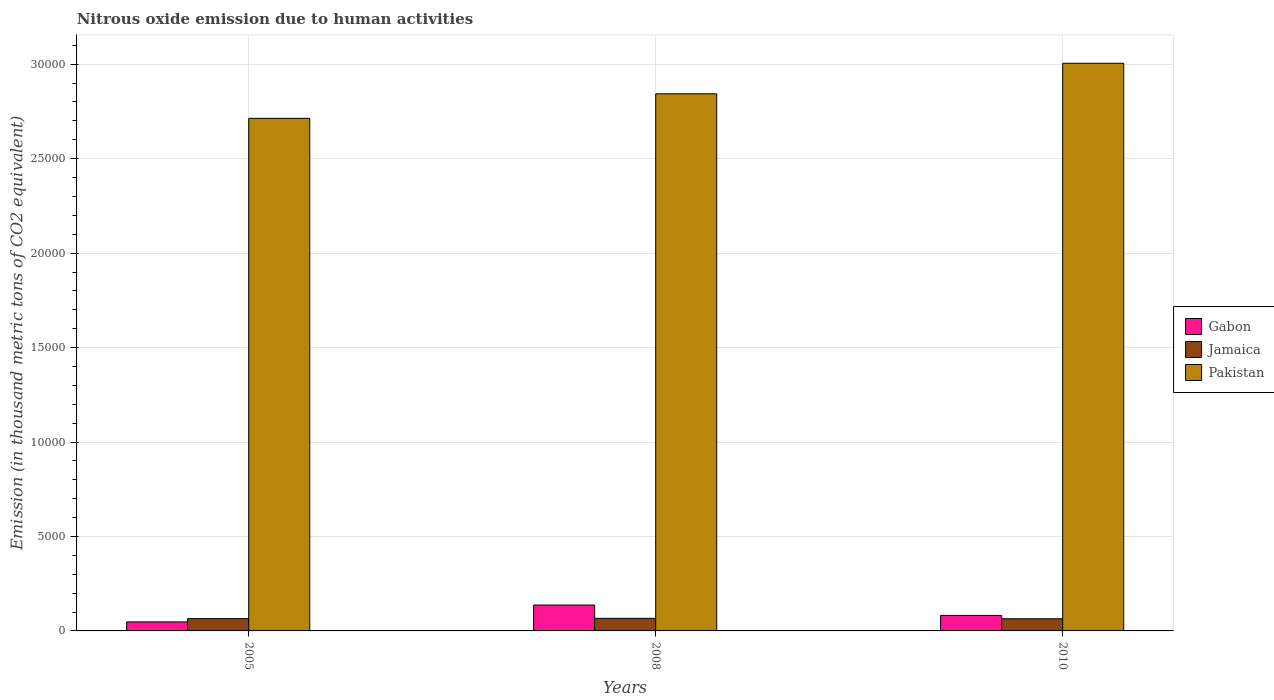Are the number of bars per tick equal to the number of legend labels?
Ensure brevity in your answer.  Yes. Are the number of bars on each tick of the X-axis equal?
Your answer should be compact. Yes. How many bars are there on the 3rd tick from the left?
Provide a short and direct response. 3. How many bars are there on the 1st tick from the right?
Offer a terse response. 3. In how many cases, is the number of bars for a given year not equal to the number of legend labels?
Ensure brevity in your answer.  0. What is the amount of nitrous oxide emitted in Jamaica in 2005?
Ensure brevity in your answer.  650.5. Across all years, what is the maximum amount of nitrous oxide emitted in Jamaica?
Your answer should be very brief. 666.6. Across all years, what is the minimum amount of nitrous oxide emitted in Pakistan?
Your answer should be very brief. 2.71e+04. In which year was the amount of nitrous oxide emitted in Pakistan maximum?
Your response must be concise. 2010. What is the total amount of nitrous oxide emitted in Gabon in the graph?
Provide a short and direct response. 2668.4. What is the difference between the amount of nitrous oxide emitted in Gabon in 2005 and that in 2010?
Your answer should be very brief. -344.2. What is the difference between the amount of nitrous oxide emitted in Pakistan in 2008 and the amount of nitrous oxide emitted in Gabon in 2005?
Provide a succinct answer. 2.80e+04. What is the average amount of nitrous oxide emitted in Jamaica per year?
Provide a succinct answer. 653.47. In the year 2005, what is the difference between the amount of nitrous oxide emitted in Gabon and amount of nitrous oxide emitted in Pakistan?
Offer a terse response. -2.67e+04. What is the ratio of the amount of nitrous oxide emitted in Pakistan in 2008 to that in 2010?
Offer a very short reply. 0.95. What is the difference between the highest and the second highest amount of nitrous oxide emitted in Pakistan?
Keep it short and to the point. 1617.1. What is the difference between the highest and the lowest amount of nitrous oxide emitted in Jamaica?
Provide a short and direct response. 23.3. What does the 2nd bar from the left in 2010 represents?
Your response must be concise. Jamaica. What does the 2nd bar from the right in 2010 represents?
Offer a very short reply. Jamaica. Does the graph contain any zero values?
Provide a short and direct response. No. Where does the legend appear in the graph?
Make the answer very short. Center right. How many legend labels are there?
Your answer should be compact. 3. How are the legend labels stacked?
Offer a very short reply. Vertical. What is the title of the graph?
Ensure brevity in your answer.  Nitrous oxide emission due to human activities. What is the label or title of the Y-axis?
Offer a terse response. Emission (in thousand metric tons of CO2 equivalent). What is the Emission (in thousand metric tons of CO2 equivalent) of Gabon in 2005?
Make the answer very short. 477.1. What is the Emission (in thousand metric tons of CO2 equivalent) of Jamaica in 2005?
Keep it short and to the point. 650.5. What is the Emission (in thousand metric tons of CO2 equivalent) in Pakistan in 2005?
Provide a succinct answer. 2.71e+04. What is the Emission (in thousand metric tons of CO2 equivalent) in Gabon in 2008?
Provide a succinct answer. 1370. What is the Emission (in thousand metric tons of CO2 equivalent) of Jamaica in 2008?
Your answer should be very brief. 666.6. What is the Emission (in thousand metric tons of CO2 equivalent) in Pakistan in 2008?
Give a very brief answer. 2.84e+04. What is the Emission (in thousand metric tons of CO2 equivalent) of Gabon in 2010?
Keep it short and to the point. 821.3. What is the Emission (in thousand metric tons of CO2 equivalent) in Jamaica in 2010?
Provide a succinct answer. 643.3. What is the Emission (in thousand metric tons of CO2 equivalent) of Pakistan in 2010?
Your response must be concise. 3.01e+04. Across all years, what is the maximum Emission (in thousand metric tons of CO2 equivalent) of Gabon?
Ensure brevity in your answer.  1370. Across all years, what is the maximum Emission (in thousand metric tons of CO2 equivalent) in Jamaica?
Give a very brief answer. 666.6. Across all years, what is the maximum Emission (in thousand metric tons of CO2 equivalent) of Pakistan?
Your answer should be very brief. 3.01e+04. Across all years, what is the minimum Emission (in thousand metric tons of CO2 equivalent) in Gabon?
Offer a terse response. 477.1. Across all years, what is the minimum Emission (in thousand metric tons of CO2 equivalent) of Jamaica?
Your answer should be very brief. 643.3. Across all years, what is the minimum Emission (in thousand metric tons of CO2 equivalent) in Pakistan?
Offer a very short reply. 2.71e+04. What is the total Emission (in thousand metric tons of CO2 equivalent) in Gabon in the graph?
Make the answer very short. 2668.4. What is the total Emission (in thousand metric tons of CO2 equivalent) of Jamaica in the graph?
Offer a very short reply. 1960.4. What is the total Emission (in thousand metric tons of CO2 equivalent) in Pakistan in the graph?
Ensure brevity in your answer.  8.56e+04. What is the difference between the Emission (in thousand metric tons of CO2 equivalent) in Gabon in 2005 and that in 2008?
Offer a very short reply. -892.9. What is the difference between the Emission (in thousand metric tons of CO2 equivalent) of Jamaica in 2005 and that in 2008?
Offer a terse response. -16.1. What is the difference between the Emission (in thousand metric tons of CO2 equivalent) of Pakistan in 2005 and that in 2008?
Give a very brief answer. -1298.6. What is the difference between the Emission (in thousand metric tons of CO2 equivalent) in Gabon in 2005 and that in 2010?
Make the answer very short. -344.2. What is the difference between the Emission (in thousand metric tons of CO2 equivalent) in Jamaica in 2005 and that in 2010?
Ensure brevity in your answer.  7.2. What is the difference between the Emission (in thousand metric tons of CO2 equivalent) of Pakistan in 2005 and that in 2010?
Provide a short and direct response. -2915.7. What is the difference between the Emission (in thousand metric tons of CO2 equivalent) in Gabon in 2008 and that in 2010?
Ensure brevity in your answer.  548.7. What is the difference between the Emission (in thousand metric tons of CO2 equivalent) of Jamaica in 2008 and that in 2010?
Make the answer very short. 23.3. What is the difference between the Emission (in thousand metric tons of CO2 equivalent) of Pakistan in 2008 and that in 2010?
Offer a very short reply. -1617.1. What is the difference between the Emission (in thousand metric tons of CO2 equivalent) in Gabon in 2005 and the Emission (in thousand metric tons of CO2 equivalent) in Jamaica in 2008?
Keep it short and to the point. -189.5. What is the difference between the Emission (in thousand metric tons of CO2 equivalent) of Gabon in 2005 and the Emission (in thousand metric tons of CO2 equivalent) of Pakistan in 2008?
Ensure brevity in your answer.  -2.80e+04. What is the difference between the Emission (in thousand metric tons of CO2 equivalent) of Jamaica in 2005 and the Emission (in thousand metric tons of CO2 equivalent) of Pakistan in 2008?
Provide a succinct answer. -2.78e+04. What is the difference between the Emission (in thousand metric tons of CO2 equivalent) of Gabon in 2005 and the Emission (in thousand metric tons of CO2 equivalent) of Jamaica in 2010?
Offer a terse response. -166.2. What is the difference between the Emission (in thousand metric tons of CO2 equivalent) of Gabon in 2005 and the Emission (in thousand metric tons of CO2 equivalent) of Pakistan in 2010?
Your answer should be very brief. -2.96e+04. What is the difference between the Emission (in thousand metric tons of CO2 equivalent) in Jamaica in 2005 and the Emission (in thousand metric tons of CO2 equivalent) in Pakistan in 2010?
Give a very brief answer. -2.94e+04. What is the difference between the Emission (in thousand metric tons of CO2 equivalent) of Gabon in 2008 and the Emission (in thousand metric tons of CO2 equivalent) of Jamaica in 2010?
Make the answer very short. 726.7. What is the difference between the Emission (in thousand metric tons of CO2 equivalent) of Gabon in 2008 and the Emission (in thousand metric tons of CO2 equivalent) of Pakistan in 2010?
Offer a very short reply. -2.87e+04. What is the difference between the Emission (in thousand metric tons of CO2 equivalent) in Jamaica in 2008 and the Emission (in thousand metric tons of CO2 equivalent) in Pakistan in 2010?
Offer a terse response. -2.94e+04. What is the average Emission (in thousand metric tons of CO2 equivalent) in Gabon per year?
Give a very brief answer. 889.47. What is the average Emission (in thousand metric tons of CO2 equivalent) in Jamaica per year?
Offer a very short reply. 653.47. What is the average Emission (in thousand metric tons of CO2 equivalent) of Pakistan per year?
Offer a terse response. 2.85e+04. In the year 2005, what is the difference between the Emission (in thousand metric tons of CO2 equivalent) of Gabon and Emission (in thousand metric tons of CO2 equivalent) of Jamaica?
Your answer should be very brief. -173.4. In the year 2005, what is the difference between the Emission (in thousand metric tons of CO2 equivalent) of Gabon and Emission (in thousand metric tons of CO2 equivalent) of Pakistan?
Offer a very short reply. -2.67e+04. In the year 2005, what is the difference between the Emission (in thousand metric tons of CO2 equivalent) in Jamaica and Emission (in thousand metric tons of CO2 equivalent) in Pakistan?
Offer a very short reply. -2.65e+04. In the year 2008, what is the difference between the Emission (in thousand metric tons of CO2 equivalent) in Gabon and Emission (in thousand metric tons of CO2 equivalent) in Jamaica?
Offer a terse response. 703.4. In the year 2008, what is the difference between the Emission (in thousand metric tons of CO2 equivalent) in Gabon and Emission (in thousand metric tons of CO2 equivalent) in Pakistan?
Keep it short and to the point. -2.71e+04. In the year 2008, what is the difference between the Emission (in thousand metric tons of CO2 equivalent) in Jamaica and Emission (in thousand metric tons of CO2 equivalent) in Pakistan?
Make the answer very short. -2.78e+04. In the year 2010, what is the difference between the Emission (in thousand metric tons of CO2 equivalent) in Gabon and Emission (in thousand metric tons of CO2 equivalent) in Jamaica?
Keep it short and to the point. 178. In the year 2010, what is the difference between the Emission (in thousand metric tons of CO2 equivalent) of Gabon and Emission (in thousand metric tons of CO2 equivalent) of Pakistan?
Your answer should be very brief. -2.92e+04. In the year 2010, what is the difference between the Emission (in thousand metric tons of CO2 equivalent) of Jamaica and Emission (in thousand metric tons of CO2 equivalent) of Pakistan?
Your response must be concise. -2.94e+04. What is the ratio of the Emission (in thousand metric tons of CO2 equivalent) of Gabon in 2005 to that in 2008?
Offer a terse response. 0.35. What is the ratio of the Emission (in thousand metric tons of CO2 equivalent) in Jamaica in 2005 to that in 2008?
Offer a terse response. 0.98. What is the ratio of the Emission (in thousand metric tons of CO2 equivalent) in Pakistan in 2005 to that in 2008?
Offer a very short reply. 0.95. What is the ratio of the Emission (in thousand metric tons of CO2 equivalent) in Gabon in 2005 to that in 2010?
Your response must be concise. 0.58. What is the ratio of the Emission (in thousand metric tons of CO2 equivalent) in Jamaica in 2005 to that in 2010?
Provide a short and direct response. 1.01. What is the ratio of the Emission (in thousand metric tons of CO2 equivalent) in Pakistan in 2005 to that in 2010?
Ensure brevity in your answer.  0.9. What is the ratio of the Emission (in thousand metric tons of CO2 equivalent) in Gabon in 2008 to that in 2010?
Keep it short and to the point. 1.67. What is the ratio of the Emission (in thousand metric tons of CO2 equivalent) in Jamaica in 2008 to that in 2010?
Your answer should be compact. 1.04. What is the ratio of the Emission (in thousand metric tons of CO2 equivalent) of Pakistan in 2008 to that in 2010?
Your answer should be very brief. 0.95. What is the difference between the highest and the second highest Emission (in thousand metric tons of CO2 equivalent) in Gabon?
Keep it short and to the point. 548.7. What is the difference between the highest and the second highest Emission (in thousand metric tons of CO2 equivalent) in Pakistan?
Provide a short and direct response. 1617.1. What is the difference between the highest and the lowest Emission (in thousand metric tons of CO2 equivalent) in Gabon?
Ensure brevity in your answer.  892.9. What is the difference between the highest and the lowest Emission (in thousand metric tons of CO2 equivalent) of Jamaica?
Offer a very short reply. 23.3. What is the difference between the highest and the lowest Emission (in thousand metric tons of CO2 equivalent) of Pakistan?
Provide a short and direct response. 2915.7. 